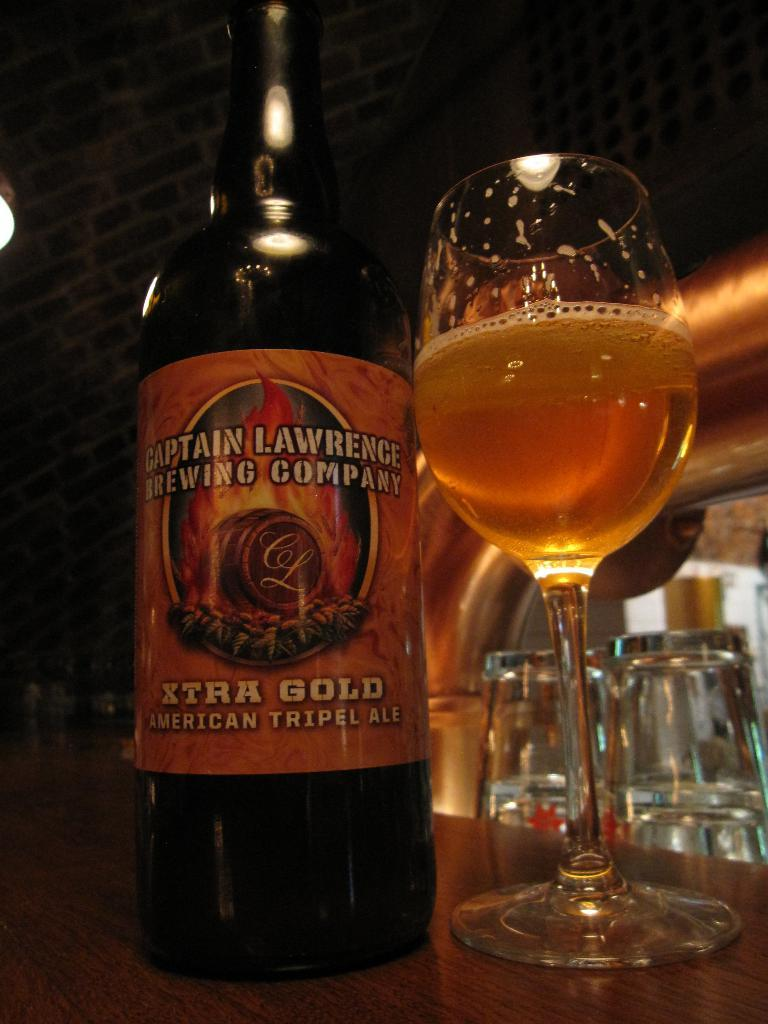<image>
Relay a brief, clear account of the picture shown. Captain Lawrence Brewing Company Xtra Gold American Triple Ale poured in a glass of wine. 